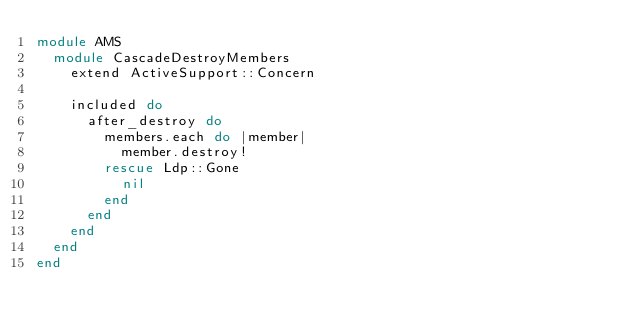Convert code to text. <code><loc_0><loc_0><loc_500><loc_500><_Ruby_>module AMS
  module CascadeDestroyMembers
    extend ActiveSupport::Concern

    included do
      after_destroy do
        members.each do |member|
          member.destroy!
        rescue Ldp::Gone
          nil
        end
      end
    end
  end
end
</code> 